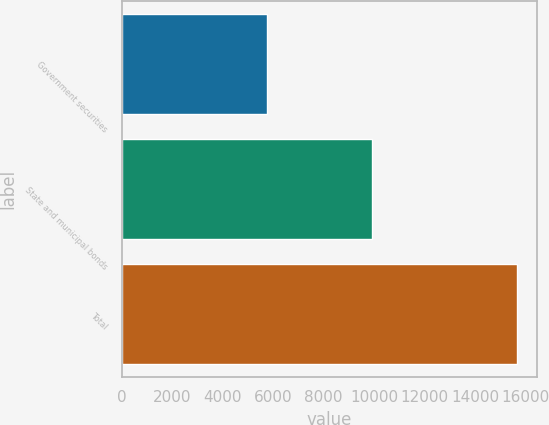Convert chart. <chart><loc_0><loc_0><loc_500><loc_500><bar_chart><fcel>Government securities<fcel>State and municipal bonds<fcel>Total<nl><fcel>5755<fcel>9923<fcel>15678<nl></chart> 